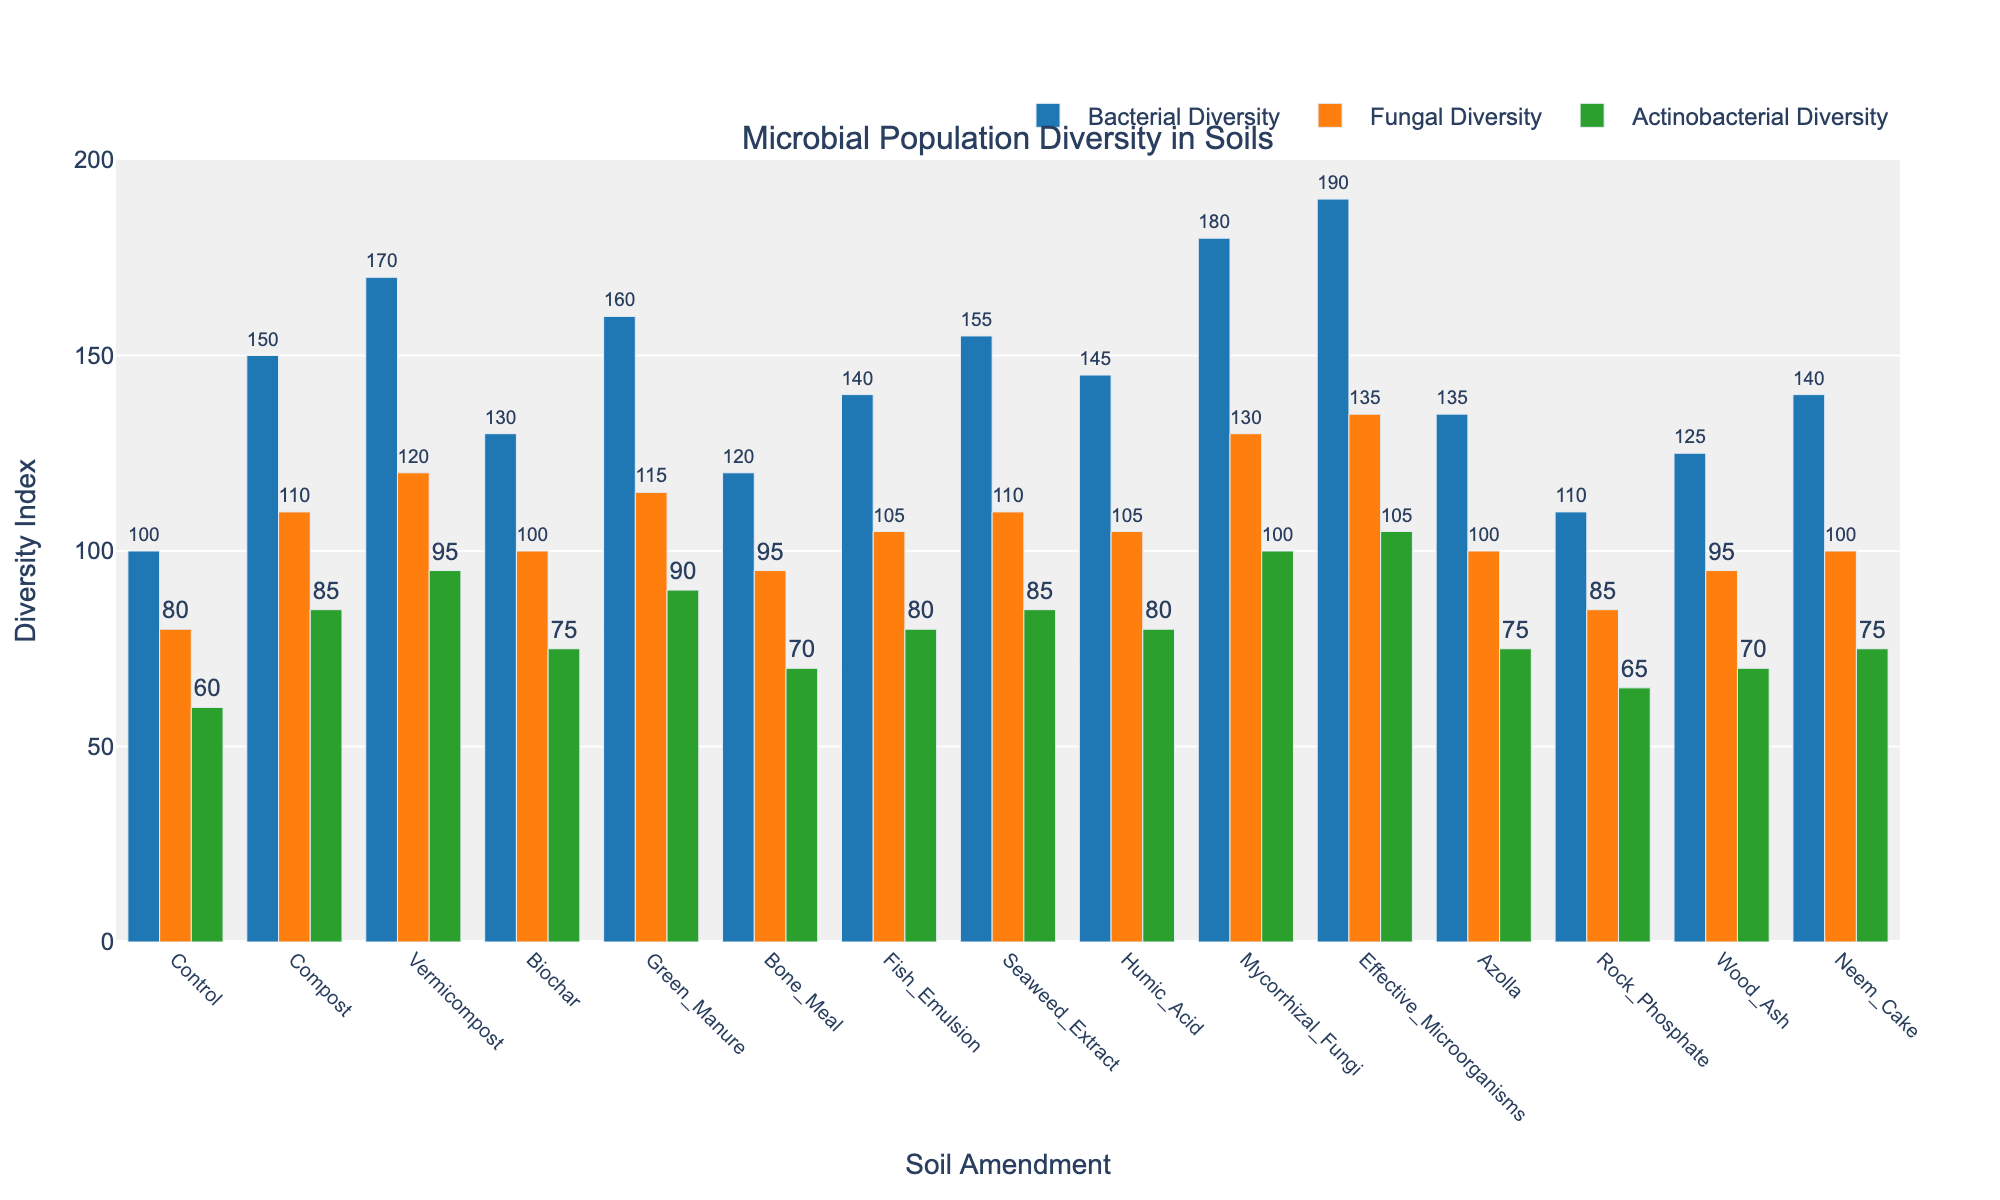Which soil amendment results in the highest bacterial diversity? Look at the bars for "Bacterial Diversity" and identify the tallest one. The amendment with the tallest bar (190) is "Effective Microorganisms".
Answer: Effective Microorganisms How much higher is fungal diversity in Mycorrhizal Fungi than in Azolla? Find the heights of the "Fungal Diversity" bars for Mycorrhizal Fungi (130) and Azolla (100). Subtract the smaller value from the larger one: 130 - 100.
Answer: 30 Which soil amendment shows the lowest actinobacterial diversity? Look at the "Actinobacterial Diversity" bars and identify the shortest one (60). The corresponding amendment is "Control".
Answer: Control What is the average bacterial diversity across Compost, Vermicompost, and Green Manure? Add the "Bacterial Diversity" values for Compost (150), Vermicompost (170), and Green Manure (160). Then divide by the number of data points: (150 + 170 + 160) / 3.
Answer: 160 Compare the bacterial and fungal diversity in Biochar. Which one is higher and by how much? Identify the heights of the "Bacterial Diversity" (130) and "Fungal Diversity" (100) bars for Biochar. Subtract the fungal value from the bacterial value: 130 - 100.
Answer: Bacterial is higher by 30 Which soil amendment has similar values for fungal and actinobacterial diversity? Look for soil amendments where the “Fungal Diversity” and “Actinobacterial Diversity” bars have similar heights. “Seaweed Extract” has fungal diversity (110) and actinobacterial diversity (85).
Answer: Seaweed Extract How many soil amendments have a fungal diversity higher than 100? Count the “Fungal Diversity” bars with heights greater than 100. The amendments are Compost (110), Vermicompost (120), Green Manure (115), Fish Emulsion (105), Seaweed Extract (110), Humic Acid (105), Mycorrhizal Fungi (130), and Effective Microorganisms (135).
Answer: 8 What is the difference in actinobacterial diversity between Neem Cake and Rock Phosphate? Find the heights of the "Actinobacterial Diversity" bars for Neem Cake (75) and Rock Phosphate (65). Subtract the smaller value from the larger one: 75 - 65.
Answer: 10 Which has a higher fungal diversity, Humic Acid or Fish Emulsion, and by how much? Identify the heights of the "Fungal Diversity" bars for Humic Acid (105) and Fish Emulsion (105). Since they have the same value, the difference is zero.
Answer: They are equal What is the total actinobacterial diversity for Compost, Biochar, and Bone Meal combined? Add the "Actinobacterial Diversity" values for Compost (85), Biochar (75), and Bone Meal (70): 85 + 75 + 70.
Answer: 230 